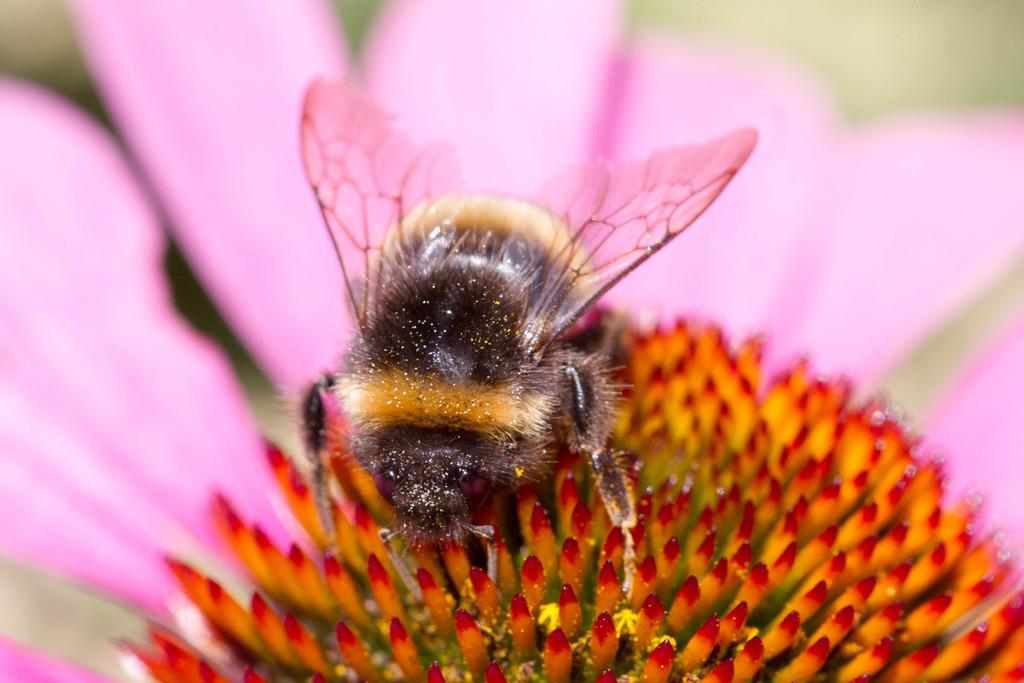What is the main subject of the image? There is a honey bee in the image. Where is the honey bee located? The honey bee is on a flower. Can you describe the background of the image? The background of the image is blurred. What is the honey bee's reaction to the existence of a mountain in the image? There is no mountain present in the image, so the honey bee's reaction cannot be determined. 